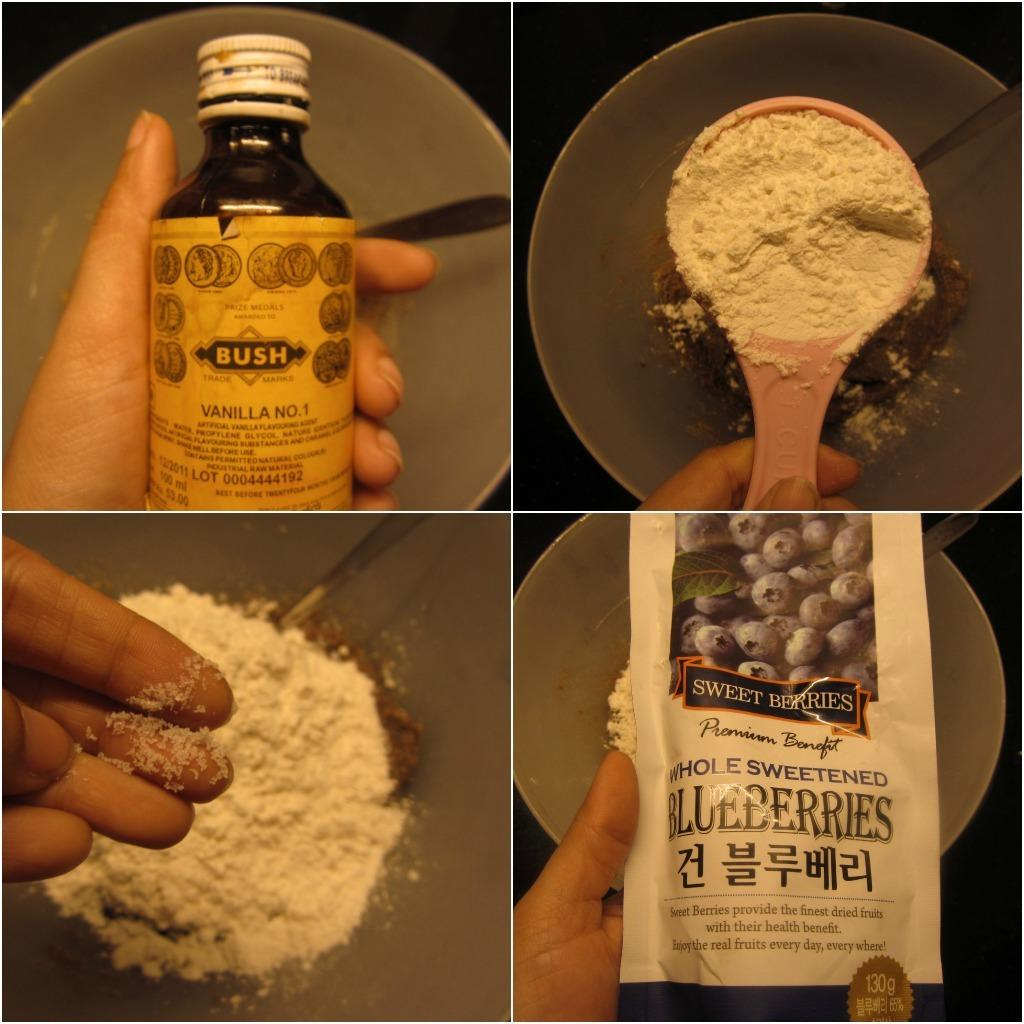<image>
Relay a brief, clear account of the picture shown. four pictures next to one another with a package of whole sweetened blueberries on the bottom right one 